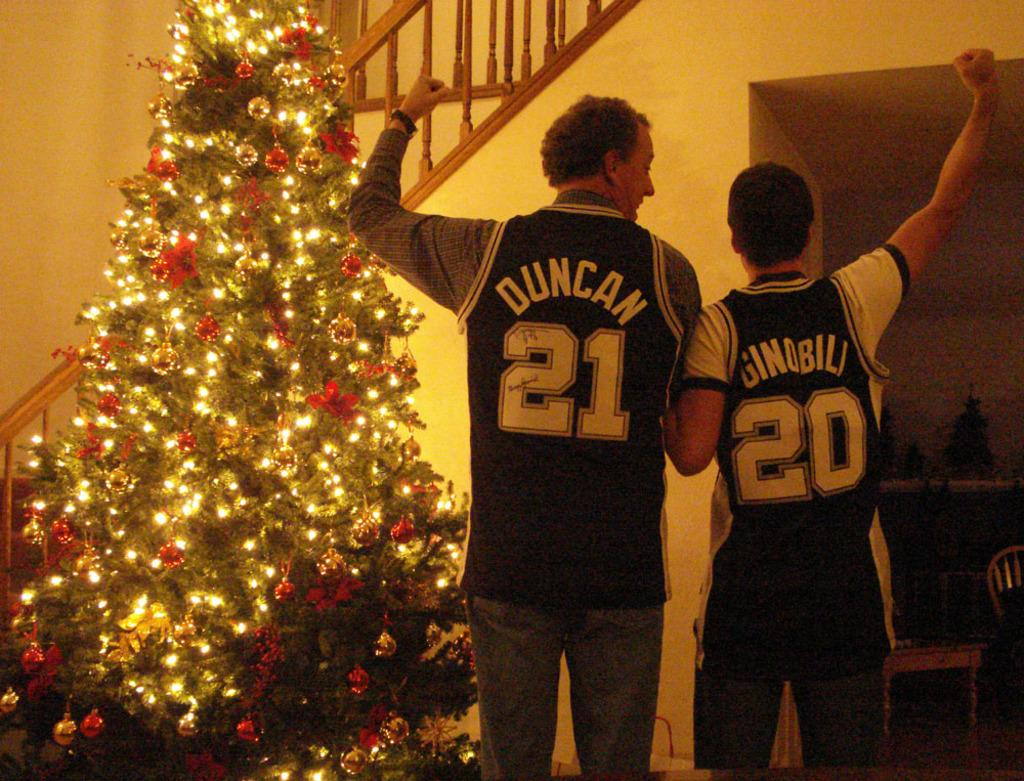<image>
Offer a succinct explanation of the picture presented. Two men in front of a Christmas tree, one of whom has the number 20 on his shirt. 